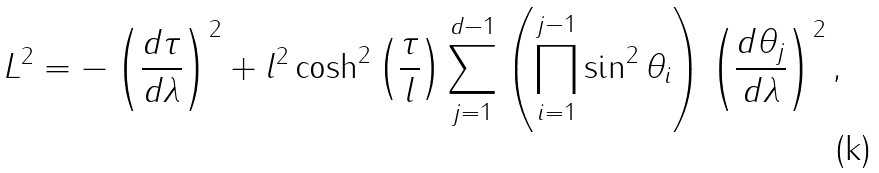<formula> <loc_0><loc_0><loc_500><loc_500>L ^ { 2 } = - \left ( \frac { d \tau } { d \lambda } \right ) ^ { 2 } + l ^ { 2 } \cosh ^ { 2 } \left ( \frac { \tau } { l } \right ) \sum _ { j = 1 } ^ { d - 1 } \left ( \prod _ { i = 1 } ^ { j - 1 } \sin ^ { 2 } \theta _ { i } \right ) \left ( \frac { d \theta _ { j } } { d \lambda } \right ) ^ { 2 } ,</formula> 